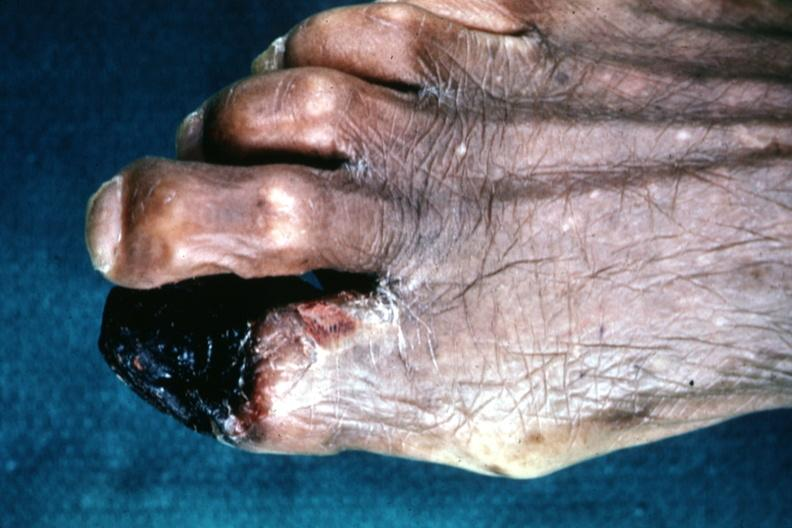what is present?
Answer the question using a single word or phrase. Gangrene 